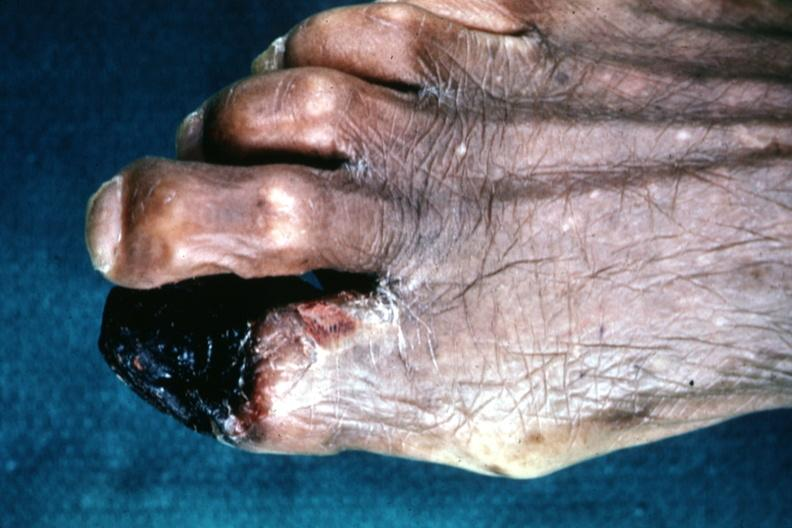what is present?
Answer the question using a single word or phrase. Gangrene 